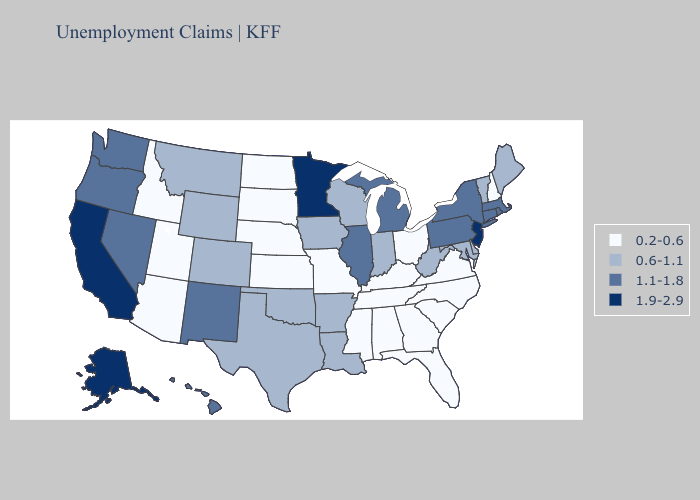Name the states that have a value in the range 1.1-1.8?
Keep it brief. Connecticut, Hawaii, Illinois, Massachusetts, Michigan, Nevada, New Mexico, New York, Oregon, Pennsylvania, Rhode Island, Washington. Among the states that border Alabama , which have the highest value?
Give a very brief answer. Florida, Georgia, Mississippi, Tennessee. Does Iowa have a lower value than Vermont?
Be succinct. No. Does the first symbol in the legend represent the smallest category?
Answer briefly. Yes. Which states have the lowest value in the USA?
Answer briefly. Alabama, Arizona, Florida, Georgia, Idaho, Kansas, Kentucky, Mississippi, Missouri, Nebraska, New Hampshire, North Carolina, North Dakota, Ohio, South Carolina, South Dakota, Tennessee, Utah, Virginia. Which states have the lowest value in the Northeast?
Be succinct. New Hampshire. Name the states that have a value in the range 0.2-0.6?
Concise answer only. Alabama, Arizona, Florida, Georgia, Idaho, Kansas, Kentucky, Mississippi, Missouri, Nebraska, New Hampshire, North Carolina, North Dakota, Ohio, South Carolina, South Dakota, Tennessee, Utah, Virginia. Name the states that have a value in the range 0.6-1.1?
Concise answer only. Arkansas, Colorado, Delaware, Indiana, Iowa, Louisiana, Maine, Maryland, Montana, Oklahoma, Texas, Vermont, West Virginia, Wisconsin, Wyoming. Does the first symbol in the legend represent the smallest category?
Quick response, please. Yes. What is the value of Hawaii?
Be succinct. 1.1-1.8. What is the lowest value in states that border New Jersey?
Concise answer only. 0.6-1.1. Which states have the highest value in the USA?
Short answer required. Alaska, California, Minnesota, New Jersey. What is the value of New Hampshire?
Keep it brief. 0.2-0.6. 